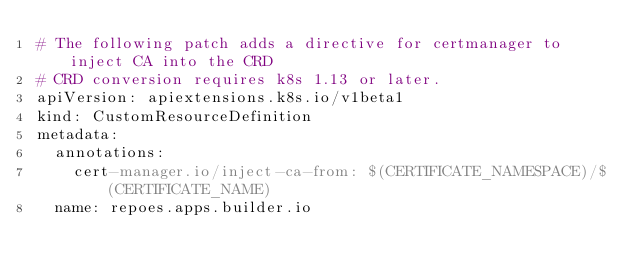Convert code to text. <code><loc_0><loc_0><loc_500><loc_500><_YAML_># The following patch adds a directive for certmanager to inject CA into the CRD
# CRD conversion requires k8s 1.13 or later.
apiVersion: apiextensions.k8s.io/v1beta1
kind: CustomResourceDefinition
metadata:
  annotations:
    cert-manager.io/inject-ca-from: $(CERTIFICATE_NAMESPACE)/$(CERTIFICATE_NAME)
  name: repoes.apps.builder.io
</code> 